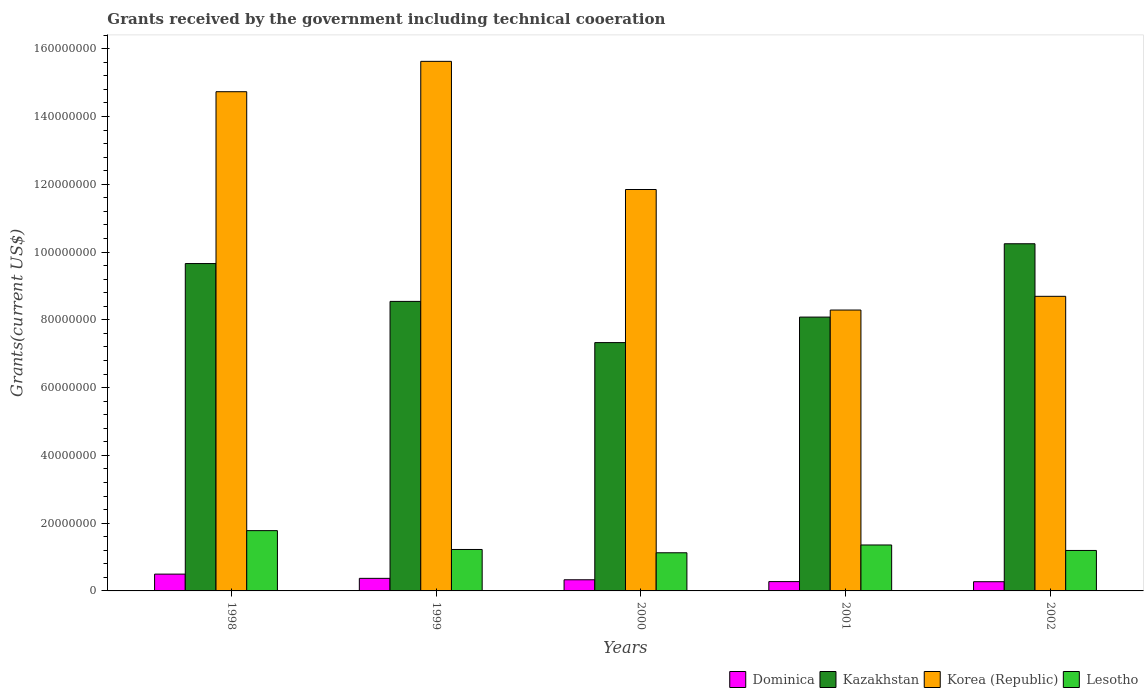How many different coloured bars are there?
Offer a terse response. 4. How many groups of bars are there?
Make the answer very short. 5. How many bars are there on the 4th tick from the right?
Ensure brevity in your answer.  4. What is the label of the 1st group of bars from the left?
Your answer should be compact. 1998. In how many cases, is the number of bars for a given year not equal to the number of legend labels?
Offer a terse response. 0. What is the total grants received by the government in Dominica in 1998?
Ensure brevity in your answer.  4.96e+06. Across all years, what is the maximum total grants received by the government in Korea (Republic)?
Make the answer very short. 1.56e+08. Across all years, what is the minimum total grants received by the government in Korea (Republic)?
Provide a short and direct response. 8.29e+07. In which year was the total grants received by the government in Kazakhstan maximum?
Keep it short and to the point. 2002. What is the total total grants received by the government in Lesotho in the graph?
Give a very brief answer. 6.68e+07. What is the difference between the total grants received by the government in Dominica in 2000 and that in 2001?
Provide a succinct answer. 5.40e+05. What is the difference between the total grants received by the government in Dominica in 2000 and the total grants received by the government in Lesotho in 1999?
Keep it short and to the point. -8.94e+06. What is the average total grants received by the government in Kazakhstan per year?
Keep it short and to the point. 8.77e+07. In the year 2001, what is the difference between the total grants received by the government in Korea (Republic) and total grants received by the government in Lesotho?
Your answer should be very brief. 6.93e+07. In how many years, is the total grants received by the government in Korea (Republic) greater than 36000000 US$?
Your answer should be compact. 5. What is the ratio of the total grants received by the government in Kazakhstan in 2000 to that in 2002?
Keep it short and to the point. 0.72. Is the total grants received by the government in Korea (Republic) in 2000 less than that in 2002?
Your response must be concise. No. What is the difference between the highest and the second highest total grants received by the government in Lesotho?
Make the answer very short. 4.23e+06. What is the difference between the highest and the lowest total grants received by the government in Kazakhstan?
Provide a short and direct response. 2.92e+07. What does the 4th bar from the left in 1999 represents?
Give a very brief answer. Lesotho. What does the 3rd bar from the right in 1998 represents?
Your answer should be very brief. Kazakhstan. How many bars are there?
Make the answer very short. 20. Are all the bars in the graph horizontal?
Your answer should be compact. No. What is the difference between two consecutive major ticks on the Y-axis?
Ensure brevity in your answer.  2.00e+07. Are the values on the major ticks of Y-axis written in scientific E-notation?
Offer a very short reply. No. How many legend labels are there?
Offer a terse response. 4. What is the title of the graph?
Provide a succinct answer. Grants received by the government including technical cooeration. What is the label or title of the Y-axis?
Offer a terse response. Grants(current US$). What is the Grants(current US$) in Dominica in 1998?
Give a very brief answer. 4.96e+06. What is the Grants(current US$) of Kazakhstan in 1998?
Your answer should be very brief. 9.66e+07. What is the Grants(current US$) of Korea (Republic) in 1998?
Provide a short and direct response. 1.47e+08. What is the Grants(current US$) of Lesotho in 1998?
Make the answer very short. 1.78e+07. What is the Grants(current US$) in Dominica in 1999?
Keep it short and to the point. 3.71e+06. What is the Grants(current US$) of Kazakhstan in 1999?
Provide a succinct answer. 8.54e+07. What is the Grants(current US$) in Korea (Republic) in 1999?
Your answer should be compact. 1.56e+08. What is the Grants(current US$) of Lesotho in 1999?
Make the answer very short. 1.22e+07. What is the Grants(current US$) in Dominica in 2000?
Ensure brevity in your answer.  3.29e+06. What is the Grants(current US$) of Kazakhstan in 2000?
Keep it short and to the point. 7.33e+07. What is the Grants(current US$) of Korea (Republic) in 2000?
Ensure brevity in your answer.  1.18e+08. What is the Grants(current US$) in Lesotho in 2000?
Make the answer very short. 1.13e+07. What is the Grants(current US$) in Dominica in 2001?
Offer a very short reply. 2.75e+06. What is the Grants(current US$) in Kazakhstan in 2001?
Your answer should be compact. 8.08e+07. What is the Grants(current US$) of Korea (Republic) in 2001?
Give a very brief answer. 8.29e+07. What is the Grants(current US$) in Lesotho in 2001?
Keep it short and to the point. 1.36e+07. What is the Grants(current US$) of Dominica in 2002?
Your answer should be very brief. 2.72e+06. What is the Grants(current US$) in Kazakhstan in 2002?
Your answer should be compact. 1.02e+08. What is the Grants(current US$) in Korea (Republic) in 2002?
Make the answer very short. 8.69e+07. What is the Grants(current US$) in Lesotho in 2002?
Offer a very short reply. 1.19e+07. Across all years, what is the maximum Grants(current US$) in Dominica?
Your answer should be very brief. 4.96e+06. Across all years, what is the maximum Grants(current US$) in Kazakhstan?
Provide a short and direct response. 1.02e+08. Across all years, what is the maximum Grants(current US$) of Korea (Republic)?
Make the answer very short. 1.56e+08. Across all years, what is the maximum Grants(current US$) of Lesotho?
Your answer should be very brief. 1.78e+07. Across all years, what is the minimum Grants(current US$) in Dominica?
Your answer should be very brief. 2.72e+06. Across all years, what is the minimum Grants(current US$) of Kazakhstan?
Make the answer very short. 7.33e+07. Across all years, what is the minimum Grants(current US$) of Korea (Republic)?
Your answer should be compact. 8.29e+07. Across all years, what is the minimum Grants(current US$) of Lesotho?
Offer a terse response. 1.13e+07. What is the total Grants(current US$) of Dominica in the graph?
Your answer should be compact. 1.74e+07. What is the total Grants(current US$) of Kazakhstan in the graph?
Ensure brevity in your answer.  4.39e+08. What is the total Grants(current US$) in Korea (Republic) in the graph?
Keep it short and to the point. 5.92e+08. What is the total Grants(current US$) of Lesotho in the graph?
Keep it short and to the point. 6.68e+07. What is the difference between the Grants(current US$) of Dominica in 1998 and that in 1999?
Your answer should be very brief. 1.25e+06. What is the difference between the Grants(current US$) in Kazakhstan in 1998 and that in 1999?
Give a very brief answer. 1.12e+07. What is the difference between the Grants(current US$) of Korea (Republic) in 1998 and that in 1999?
Your response must be concise. -8.96e+06. What is the difference between the Grants(current US$) in Lesotho in 1998 and that in 1999?
Provide a short and direct response. 5.56e+06. What is the difference between the Grants(current US$) of Dominica in 1998 and that in 2000?
Provide a short and direct response. 1.67e+06. What is the difference between the Grants(current US$) in Kazakhstan in 1998 and that in 2000?
Your answer should be compact. 2.33e+07. What is the difference between the Grants(current US$) in Korea (Republic) in 1998 and that in 2000?
Provide a succinct answer. 2.89e+07. What is the difference between the Grants(current US$) in Lesotho in 1998 and that in 2000?
Give a very brief answer. 6.53e+06. What is the difference between the Grants(current US$) in Dominica in 1998 and that in 2001?
Provide a succinct answer. 2.21e+06. What is the difference between the Grants(current US$) of Kazakhstan in 1998 and that in 2001?
Offer a terse response. 1.58e+07. What is the difference between the Grants(current US$) in Korea (Republic) in 1998 and that in 2001?
Ensure brevity in your answer.  6.44e+07. What is the difference between the Grants(current US$) in Lesotho in 1998 and that in 2001?
Give a very brief answer. 4.23e+06. What is the difference between the Grants(current US$) of Dominica in 1998 and that in 2002?
Offer a very short reply. 2.24e+06. What is the difference between the Grants(current US$) of Kazakhstan in 1998 and that in 2002?
Offer a terse response. -5.84e+06. What is the difference between the Grants(current US$) of Korea (Republic) in 1998 and that in 2002?
Your response must be concise. 6.04e+07. What is the difference between the Grants(current US$) in Lesotho in 1998 and that in 2002?
Offer a terse response. 5.85e+06. What is the difference between the Grants(current US$) of Dominica in 1999 and that in 2000?
Your response must be concise. 4.20e+05. What is the difference between the Grants(current US$) of Kazakhstan in 1999 and that in 2000?
Your response must be concise. 1.22e+07. What is the difference between the Grants(current US$) in Korea (Republic) in 1999 and that in 2000?
Your answer should be very brief. 3.78e+07. What is the difference between the Grants(current US$) in Lesotho in 1999 and that in 2000?
Ensure brevity in your answer.  9.70e+05. What is the difference between the Grants(current US$) in Dominica in 1999 and that in 2001?
Provide a short and direct response. 9.60e+05. What is the difference between the Grants(current US$) of Kazakhstan in 1999 and that in 2001?
Provide a short and direct response. 4.63e+06. What is the difference between the Grants(current US$) of Korea (Republic) in 1999 and that in 2001?
Offer a very short reply. 7.34e+07. What is the difference between the Grants(current US$) of Lesotho in 1999 and that in 2001?
Keep it short and to the point. -1.33e+06. What is the difference between the Grants(current US$) of Dominica in 1999 and that in 2002?
Your answer should be compact. 9.90e+05. What is the difference between the Grants(current US$) of Kazakhstan in 1999 and that in 2002?
Provide a succinct answer. -1.70e+07. What is the difference between the Grants(current US$) of Korea (Republic) in 1999 and that in 2002?
Provide a short and direct response. 6.93e+07. What is the difference between the Grants(current US$) in Dominica in 2000 and that in 2001?
Ensure brevity in your answer.  5.40e+05. What is the difference between the Grants(current US$) in Kazakhstan in 2000 and that in 2001?
Ensure brevity in your answer.  -7.53e+06. What is the difference between the Grants(current US$) in Korea (Republic) in 2000 and that in 2001?
Give a very brief answer. 3.56e+07. What is the difference between the Grants(current US$) of Lesotho in 2000 and that in 2001?
Offer a very short reply. -2.30e+06. What is the difference between the Grants(current US$) of Dominica in 2000 and that in 2002?
Your response must be concise. 5.70e+05. What is the difference between the Grants(current US$) in Kazakhstan in 2000 and that in 2002?
Your response must be concise. -2.92e+07. What is the difference between the Grants(current US$) in Korea (Republic) in 2000 and that in 2002?
Give a very brief answer. 3.15e+07. What is the difference between the Grants(current US$) of Lesotho in 2000 and that in 2002?
Your response must be concise. -6.80e+05. What is the difference between the Grants(current US$) in Dominica in 2001 and that in 2002?
Provide a succinct answer. 3.00e+04. What is the difference between the Grants(current US$) in Kazakhstan in 2001 and that in 2002?
Ensure brevity in your answer.  -2.16e+07. What is the difference between the Grants(current US$) in Korea (Republic) in 2001 and that in 2002?
Provide a succinct answer. -4.05e+06. What is the difference between the Grants(current US$) in Lesotho in 2001 and that in 2002?
Your answer should be very brief. 1.62e+06. What is the difference between the Grants(current US$) of Dominica in 1998 and the Grants(current US$) of Kazakhstan in 1999?
Offer a terse response. -8.05e+07. What is the difference between the Grants(current US$) of Dominica in 1998 and the Grants(current US$) of Korea (Republic) in 1999?
Provide a short and direct response. -1.51e+08. What is the difference between the Grants(current US$) in Dominica in 1998 and the Grants(current US$) in Lesotho in 1999?
Your response must be concise. -7.27e+06. What is the difference between the Grants(current US$) in Kazakhstan in 1998 and the Grants(current US$) in Korea (Republic) in 1999?
Your answer should be very brief. -5.97e+07. What is the difference between the Grants(current US$) of Kazakhstan in 1998 and the Grants(current US$) of Lesotho in 1999?
Make the answer very short. 8.44e+07. What is the difference between the Grants(current US$) of Korea (Republic) in 1998 and the Grants(current US$) of Lesotho in 1999?
Make the answer very short. 1.35e+08. What is the difference between the Grants(current US$) of Dominica in 1998 and the Grants(current US$) of Kazakhstan in 2000?
Keep it short and to the point. -6.83e+07. What is the difference between the Grants(current US$) in Dominica in 1998 and the Grants(current US$) in Korea (Republic) in 2000?
Give a very brief answer. -1.14e+08. What is the difference between the Grants(current US$) in Dominica in 1998 and the Grants(current US$) in Lesotho in 2000?
Give a very brief answer. -6.30e+06. What is the difference between the Grants(current US$) of Kazakhstan in 1998 and the Grants(current US$) of Korea (Republic) in 2000?
Offer a terse response. -2.18e+07. What is the difference between the Grants(current US$) of Kazakhstan in 1998 and the Grants(current US$) of Lesotho in 2000?
Keep it short and to the point. 8.54e+07. What is the difference between the Grants(current US$) in Korea (Republic) in 1998 and the Grants(current US$) in Lesotho in 2000?
Offer a very short reply. 1.36e+08. What is the difference between the Grants(current US$) in Dominica in 1998 and the Grants(current US$) in Kazakhstan in 2001?
Provide a short and direct response. -7.58e+07. What is the difference between the Grants(current US$) of Dominica in 1998 and the Grants(current US$) of Korea (Republic) in 2001?
Your answer should be compact. -7.79e+07. What is the difference between the Grants(current US$) in Dominica in 1998 and the Grants(current US$) in Lesotho in 2001?
Your answer should be compact. -8.60e+06. What is the difference between the Grants(current US$) of Kazakhstan in 1998 and the Grants(current US$) of Korea (Republic) in 2001?
Your response must be concise. 1.37e+07. What is the difference between the Grants(current US$) of Kazakhstan in 1998 and the Grants(current US$) of Lesotho in 2001?
Ensure brevity in your answer.  8.30e+07. What is the difference between the Grants(current US$) in Korea (Republic) in 1998 and the Grants(current US$) in Lesotho in 2001?
Offer a very short reply. 1.34e+08. What is the difference between the Grants(current US$) in Dominica in 1998 and the Grants(current US$) in Kazakhstan in 2002?
Keep it short and to the point. -9.75e+07. What is the difference between the Grants(current US$) of Dominica in 1998 and the Grants(current US$) of Korea (Republic) in 2002?
Keep it short and to the point. -8.20e+07. What is the difference between the Grants(current US$) of Dominica in 1998 and the Grants(current US$) of Lesotho in 2002?
Keep it short and to the point. -6.98e+06. What is the difference between the Grants(current US$) in Kazakhstan in 1998 and the Grants(current US$) in Korea (Republic) in 2002?
Provide a succinct answer. 9.67e+06. What is the difference between the Grants(current US$) in Kazakhstan in 1998 and the Grants(current US$) in Lesotho in 2002?
Provide a succinct answer. 8.47e+07. What is the difference between the Grants(current US$) of Korea (Republic) in 1998 and the Grants(current US$) of Lesotho in 2002?
Your answer should be compact. 1.35e+08. What is the difference between the Grants(current US$) of Dominica in 1999 and the Grants(current US$) of Kazakhstan in 2000?
Provide a succinct answer. -6.96e+07. What is the difference between the Grants(current US$) of Dominica in 1999 and the Grants(current US$) of Korea (Republic) in 2000?
Your response must be concise. -1.15e+08. What is the difference between the Grants(current US$) in Dominica in 1999 and the Grants(current US$) in Lesotho in 2000?
Provide a succinct answer. -7.55e+06. What is the difference between the Grants(current US$) of Kazakhstan in 1999 and the Grants(current US$) of Korea (Republic) in 2000?
Make the answer very short. -3.30e+07. What is the difference between the Grants(current US$) of Kazakhstan in 1999 and the Grants(current US$) of Lesotho in 2000?
Your answer should be compact. 7.42e+07. What is the difference between the Grants(current US$) of Korea (Republic) in 1999 and the Grants(current US$) of Lesotho in 2000?
Give a very brief answer. 1.45e+08. What is the difference between the Grants(current US$) in Dominica in 1999 and the Grants(current US$) in Kazakhstan in 2001?
Your answer should be compact. -7.71e+07. What is the difference between the Grants(current US$) in Dominica in 1999 and the Grants(current US$) in Korea (Republic) in 2001?
Offer a very short reply. -7.92e+07. What is the difference between the Grants(current US$) of Dominica in 1999 and the Grants(current US$) of Lesotho in 2001?
Your answer should be very brief. -9.85e+06. What is the difference between the Grants(current US$) in Kazakhstan in 1999 and the Grants(current US$) in Korea (Republic) in 2001?
Your answer should be very brief. 2.55e+06. What is the difference between the Grants(current US$) in Kazakhstan in 1999 and the Grants(current US$) in Lesotho in 2001?
Your response must be concise. 7.19e+07. What is the difference between the Grants(current US$) in Korea (Republic) in 1999 and the Grants(current US$) in Lesotho in 2001?
Make the answer very short. 1.43e+08. What is the difference between the Grants(current US$) in Dominica in 1999 and the Grants(current US$) in Kazakhstan in 2002?
Keep it short and to the point. -9.87e+07. What is the difference between the Grants(current US$) of Dominica in 1999 and the Grants(current US$) of Korea (Republic) in 2002?
Offer a terse response. -8.32e+07. What is the difference between the Grants(current US$) of Dominica in 1999 and the Grants(current US$) of Lesotho in 2002?
Give a very brief answer. -8.23e+06. What is the difference between the Grants(current US$) in Kazakhstan in 1999 and the Grants(current US$) in Korea (Republic) in 2002?
Your answer should be compact. -1.50e+06. What is the difference between the Grants(current US$) of Kazakhstan in 1999 and the Grants(current US$) of Lesotho in 2002?
Your answer should be compact. 7.35e+07. What is the difference between the Grants(current US$) of Korea (Republic) in 1999 and the Grants(current US$) of Lesotho in 2002?
Your response must be concise. 1.44e+08. What is the difference between the Grants(current US$) of Dominica in 2000 and the Grants(current US$) of Kazakhstan in 2001?
Your answer should be very brief. -7.75e+07. What is the difference between the Grants(current US$) of Dominica in 2000 and the Grants(current US$) of Korea (Republic) in 2001?
Your response must be concise. -7.96e+07. What is the difference between the Grants(current US$) in Dominica in 2000 and the Grants(current US$) in Lesotho in 2001?
Offer a very short reply. -1.03e+07. What is the difference between the Grants(current US$) of Kazakhstan in 2000 and the Grants(current US$) of Korea (Republic) in 2001?
Ensure brevity in your answer.  -9.61e+06. What is the difference between the Grants(current US$) in Kazakhstan in 2000 and the Grants(current US$) in Lesotho in 2001?
Give a very brief answer. 5.97e+07. What is the difference between the Grants(current US$) of Korea (Republic) in 2000 and the Grants(current US$) of Lesotho in 2001?
Your response must be concise. 1.05e+08. What is the difference between the Grants(current US$) of Dominica in 2000 and the Grants(current US$) of Kazakhstan in 2002?
Your answer should be very brief. -9.92e+07. What is the difference between the Grants(current US$) of Dominica in 2000 and the Grants(current US$) of Korea (Republic) in 2002?
Make the answer very short. -8.36e+07. What is the difference between the Grants(current US$) in Dominica in 2000 and the Grants(current US$) in Lesotho in 2002?
Provide a succinct answer. -8.65e+06. What is the difference between the Grants(current US$) of Kazakhstan in 2000 and the Grants(current US$) of Korea (Republic) in 2002?
Give a very brief answer. -1.37e+07. What is the difference between the Grants(current US$) of Kazakhstan in 2000 and the Grants(current US$) of Lesotho in 2002?
Provide a short and direct response. 6.13e+07. What is the difference between the Grants(current US$) of Korea (Republic) in 2000 and the Grants(current US$) of Lesotho in 2002?
Your response must be concise. 1.07e+08. What is the difference between the Grants(current US$) of Dominica in 2001 and the Grants(current US$) of Kazakhstan in 2002?
Provide a short and direct response. -9.97e+07. What is the difference between the Grants(current US$) of Dominica in 2001 and the Grants(current US$) of Korea (Republic) in 2002?
Provide a succinct answer. -8.42e+07. What is the difference between the Grants(current US$) of Dominica in 2001 and the Grants(current US$) of Lesotho in 2002?
Make the answer very short. -9.19e+06. What is the difference between the Grants(current US$) in Kazakhstan in 2001 and the Grants(current US$) in Korea (Republic) in 2002?
Your answer should be compact. -6.13e+06. What is the difference between the Grants(current US$) of Kazakhstan in 2001 and the Grants(current US$) of Lesotho in 2002?
Make the answer very short. 6.89e+07. What is the difference between the Grants(current US$) of Korea (Republic) in 2001 and the Grants(current US$) of Lesotho in 2002?
Your answer should be very brief. 7.10e+07. What is the average Grants(current US$) in Dominica per year?
Your answer should be compact. 3.49e+06. What is the average Grants(current US$) in Kazakhstan per year?
Provide a succinct answer. 8.77e+07. What is the average Grants(current US$) of Korea (Republic) per year?
Offer a terse response. 1.18e+08. What is the average Grants(current US$) of Lesotho per year?
Provide a short and direct response. 1.34e+07. In the year 1998, what is the difference between the Grants(current US$) in Dominica and Grants(current US$) in Kazakhstan?
Your answer should be very brief. -9.16e+07. In the year 1998, what is the difference between the Grants(current US$) of Dominica and Grants(current US$) of Korea (Republic)?
Keep it short and to the point. -1.42e+08. In the year 1998, what is the difference between the Grants(current US$) in Dominica and Grants(current US$) in Lesotho?
Your answer should be very brief. -1.28e+07. In the year 1998, what is the difference between the Grants(current US$) of Kazakhstan and Grants(current US$) of Korea (Republic)?
Offer a terse response. -5.07e+07. In the year 1998, what is the difference between the Grants(current US$) in Kazakhstan and Grants(current US$) in Lesotho?
Give a very brief answer. 7.88e+07. In the year 1998, what is the difference between the Grants(current US$) of Korea (Republic) and Grants(current US$) of Lesotho?
Your response must be concise. 1.30e+08. In the year 1999, what is the difference between the Grants(current US$) in Dominica and Grants(current US$) in Kazakhstan?
Ensure brevity in your answer.  -8.17e+07. In the year 1999, what is the difference between the Grants(current US$) of Dominica and Grants(current US$) of Korea (Republic)?
Ensure brevity in your answer.  -1.53e+08. In the year 1999, what is the difference between the Grants(current US$) in Dominica and Grants(current US$) in Lesotho?
Give a very brief answer. -8.52e+06. In the year 1999, what is the difference between the Grants(current US$) of Kazakhstan and Grants(current US$) of Korea (Republic)?
Ensure brevity in your answer.  -7.08e+07. In the year 1999, what is the difference between the Grants(current US$) of Kazakhstan and Grants(current US$) of Lesotho?
Your response must be concise. 7.32e+07. In the year 1999, what is the difference between the Grants(current US$) in Korea (Republic) and Grants(current US$) in Lesotho?
Offer a terse response. 1.44e+08. In the year 2000, what is the difference between the Grants(current US$) of Dominica and Grants(current US$) of Kazakhstan?
Your answer should be compact. -7.00e+07. In the year 2000, what is the difference between the Grants(current US$) of Dominica and Grants(current US$) of Korea (Republic)?
Your answer should be compact. -1.15e+08. In the year 2000, what is the difference between the Grants(current US$) in Dominica and Grants(current US$) in Lesotho?
Make the answer very short. -7.97e+06. In the year 2000, what is the difference between the Grants(current US$) of Kazakhstan and Grants(current US$) of Korea (Republic)?
Offer a very short reply. -4.52e+07. In the year 2000, what is the difference between the Grants(current US$) of Kazakhstan and Grants(current US$) of Lesotho?
Keep it short and to the point. 6.20e+07. In the year 2000, what is the difference between the Grants(current US$) in Korea (Republic) and Grants(current US$) in Lesotho?
Your response must be concise. 1.07e+08. In the year 2001, what is the difference between the Grants(current US$) in Dominica and Grants(current US$) in Kazakhstan?
Offer a very short reply. -7.81e+07. In the year 2001, what is the difference between the Grants(current US$) of Dominica and Grants(current US$) of Korea (Republic)?
Offer a very short reply. -8.01e+07. In the year 2001, what is the difference between the Grants(current US$) in Dominica and Grants(current US$) in Lesotho?
Keep it short and to the point. -1.08e+07. In the year 2001, what is the difference between the Grants(current US$) in Kazakhstan and Grants(current US$) in Korea (Republic)?
Give a very brief answer. -2.08e+06. In the year 2001, what is the difference between the Grants(current US$) in Kazakhstan and Grants(current US$) in Lesotho?
Provide a short and direct response. 6.72e+07. In the year 2001, what is the difference between the Grants(current US$) of Korea (Republic) and Grants(current US$) of Lesotho?
Provide a succinct answer. 6.93e+07. In the year 2002, what is the difference between the Grants(current US$) of Dominica and Grants(current US$) of Kazakhstan?
Offer a very short reply. -9.97e+07. In the year 2002, what is the difference between the Grants(current US$) in Dominica and Grants(current US$) in Korea (Republic)?
Ensure brevity in your answer.  -8.42e+07. In the year 2002, what is the difference between the Grants(current US$) in Dominica and Grants(current US$) in Lesotho?
Give a very brief answer. -9.22e+06. In the year 2002, what is the difference between the Grants(current US$) in Kazakhstan and Grants(current US$) in Korea (Republic)?
Provide a succinct answer. 1.55e+07. In the year 2002, what is the difference between the Grants(current US$) of Kazakhstan and Grants(current US$) of Lesotho?
Keep it short and to the point. 9.05e+07. In the year 2002, what is the difference between the Grants(current US$) in Korea (Republic) and Grants(current US$) in Lesotho?
Keep it short and to the point. 7.50e+07. What is the ratio of the Grants(current US$) in Dominica in 1998 to that in 1999?
Give a very brief answer. 1.34. What is the ratio of the Grants(current US$) of Kazakhstan in 1998 to that in 1999?
Keep it short and to the point. 1.13. What is the ratio of the Grants(current US$) in Korea (Republic) in 1998 to that in 1999?
Offer a terse response. 0.94. What is the ratio of the Grants(current US$) of Lesotho in 1998 to that in 1999?
Give a very brief answer. 1.45. What is the ratio of the Grants(current US$) of Dominica in 1998 to that in 2000?
Offer a terse response. 1.51. What is the ratio of the Grants(current US$) in Kazakhstan in 1998 to that in 2000?
Keep it short and to the point. 1.32. What is the ratio of the Grants(current US$) of Korea (Republic) in 1998 to that in 2000?
Ensure brevity in your answer.  1.24. What is the ratio of the Grants(current US$) of Lesotho in 1998 to that in 2000?
Give a very brief answer. 1.58. What is the ratio of the Grants(current US$) of Dominica in 1998 to that in 2001?
Keep it short and to the point. 1.8. What is the ratio of the Grants(current US$) of Kazakhstan in 1998 to that in 2001?
Make the answer very short. 1.2. What is the ratio of the Grants(current US$) in Korea (Republic) in 1998 to that in 2001?
Ensure brevity in your answer.  1.78. What is the ratio of the Grants(current US$) in Lesotho in 1998 to that in 2001?
Ensure brevity in your answer.  1.31. What is the ratio of the Grants(current US$) of Dominica in 1998 to that in 2002?
Your response must be concise. 1.82. What is the ratio of the Grants(current US$) of Kazakhstan in 1998 to that in 2002?
Provide a short and direct response. 0.94. What is the ratio of the Grants(current US$) of Korea (Republic) in 1998 to that in 2002?
Offer a very short reply. 1.69. What is the ratio of the Grants(current US$) in Lesotho in 1998 to that in 2002?
Your answer should be very brief. 1.49. What is the ratio of the Grants(current US$) of Dominica in 1999 to that in 2000?
Offer a terse response. 1.13. What is the ratio of the Grants(current US$) in Kazakhstan in 1999 to that in 2000?
Make the answer very short. 1.17. What is the ratio of the Grants(current US$) of Korea (Republic) in 1999 to that in 2000?
Provide a succinct answer. 1.32. What is the ratio of the Grants(current US$) in Lesotho in 1999 to that in 2000?
Your answer should be compact. 1.09. What is the ratio of the Grants(current US$) in Dominica in 1999 to that in 2001?
Ensure brevity in your answer.  1.35. What is the ratio of the Grants(current US$) of Kazakhstan in 1999 to that in 2001?
Your response must be concise. 1.06. What is the ratio of the Grants(current US$) of Korea (Republic) in 1999 to that in 2001?
Provide a short and direct response. 1.89. What is the ratio of the Grants(current US$) in Lesotho in 1999 to that in 2001?
Offer a very short reply. 0.9. What is the ratio of the Grants(current US$) in Dominica in 1999 to that in 2002?
Your answer should be compact. 1.36. What is the ratio of the Grants(current US$) in Kazakhstan in 1999 to that in 2002?
Provide a succinct answer. 0.83. What is the ratio of the Grants(current US$) in Korea (Republic) in 1999 to that in 2002?
Offer a terse response. 1.8. What is the ratio of the Grants(current US$) in Lesotho in 1999 to that in 2002?
Keep it short and to the point. 1.02. What is the ratio of the Grants(current US$) in Dominica in 2000 to that in 2001?
Make the answer very short. 1.2. What is the ratio of the Grants(current US$) in Kazakhstan in 2000 to that in 2001?
Your answer should be compact. 0.91. What is the ratio of the Grants(current US$) of Korea (Republic) in 2000 to that in 2001?
Offer a very short reply. 1.43. What is the ratio of the Grants(current US$) of Lesotho in 2000 to that in 2001?
Provide a succinct answer. 0.83. What is the ratio of the Grants(current US$) of Dominica in 2000 to that in 2002?
Give a very brief answer. 1.21. What is the ratio of the Grants(current US$) of Kazakhstan in 2000 to that in 2002?
Ensure brevity in your answer.  0.72. What is the ratio of the Grants(current US$) in Korea (Republic) in 2000 to that in 2002?
Ensure brevity in your answer.  1.36. What is the ratio of the Grants(current US$) of Lesotho in 2000 to that in 2002?
Your answer should be compact. 0.94. What is the ratio of the Grants(current US$) of Kazakhstan in 2001 to that in 2002?
Make the answer very short. 0.79. What is the ratio of the Grants(current US$) in Korea (Republic) in 2001 to that in 2002?
Give a very brief answer. 0.95. What is the ratio of the Grants(current US$) in Lesotho in 2001 to that in 2002?
Make the answer very short. 1.14. What is the difference between the highest and the second highest Grants(current US$) of Dominica?
Give a very brief answer. 1.25e+06. What is the difference between the highest and the second highest Grants(current US$) in Kazakhstan?
Offer a very short reply. 5.84e+06. What is the difference between the highest and the second highest Grants(current US$) of Korea (Republic)?
Your answer should be very brief. 8.96e+06. What is the difference between the highest and the second highest Grants(current US$) of Lesotho?
Your answer should be very brief. 4.23e+06. What is the difference between the highest and the lowest Grants(current US$) in Dominica?
Give a very brief answer. 2.24e+06. What is the difference between the highest and the lowest Grants(current US$) of Kazakhstan?
Your answer should be very brief. 2.92e+07. What is the difference between the highest and the lowest Grants(current US$) of Korea (Republic)?
Make the answer very short. 7.34e+07. What is the difference between the highest and the lowest Grants(current US$) in Lesotho?
Offer a very short reply. 6.53e+06. 